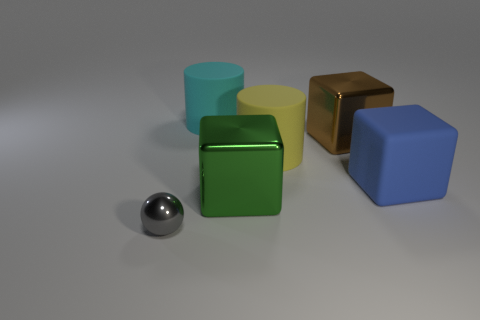Add 3 cyan shiny cubes. How many objects exist? 9 Subtract all cylinders. How many objects are left? 4 Add 4 green metallic cubes. How many green metallic cubes exist? 5 Subtract 0 cyan balls. How many objects are left? 6 Subtract all large blue cubes. Subtract all gray objects. How many objects are left? 4 Add 5 shiny cubes. How many shiny cubes are left? 7 